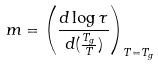<formula> <loc_0><loc_0><loc_500><loc_500>m = \left ( \frac { d \log \tau } { d ( \frac { T _ { g } } { T } ) } \right ) _ { T = T _ { g } }</formula> 